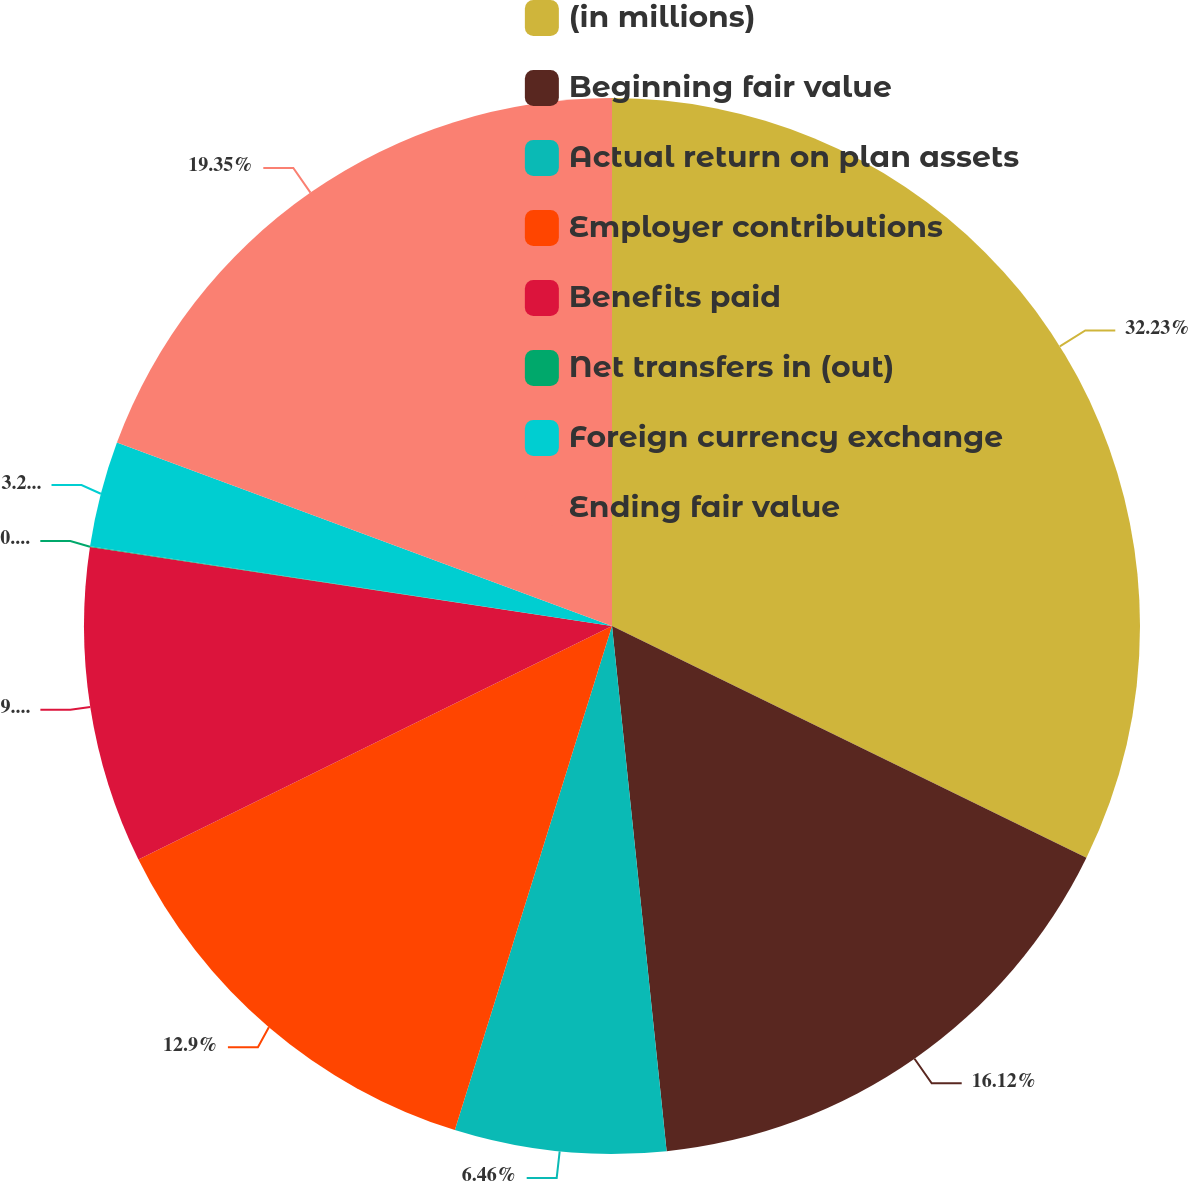Convert chart to OTSL. <chart><loc_0><loc_0><loc_500><loc_500><pie_chart><fcel>(in millions)<fcel>Beginning fair value<fcel>Actual return on plan assets<fcel>Employer contributions<fcel>Benefits paid<fcel>Net transfers in (out)<fcel>Foreign currency exchange<fcel>Ending fair value<nl><fcel>32.23%<fcel>16.12%<fcel>6.46%<fcel>12.9%<fcel>9.68%<fcel>0.02%<fcel>3.24%<fcel>19.35%<nl></chart> 